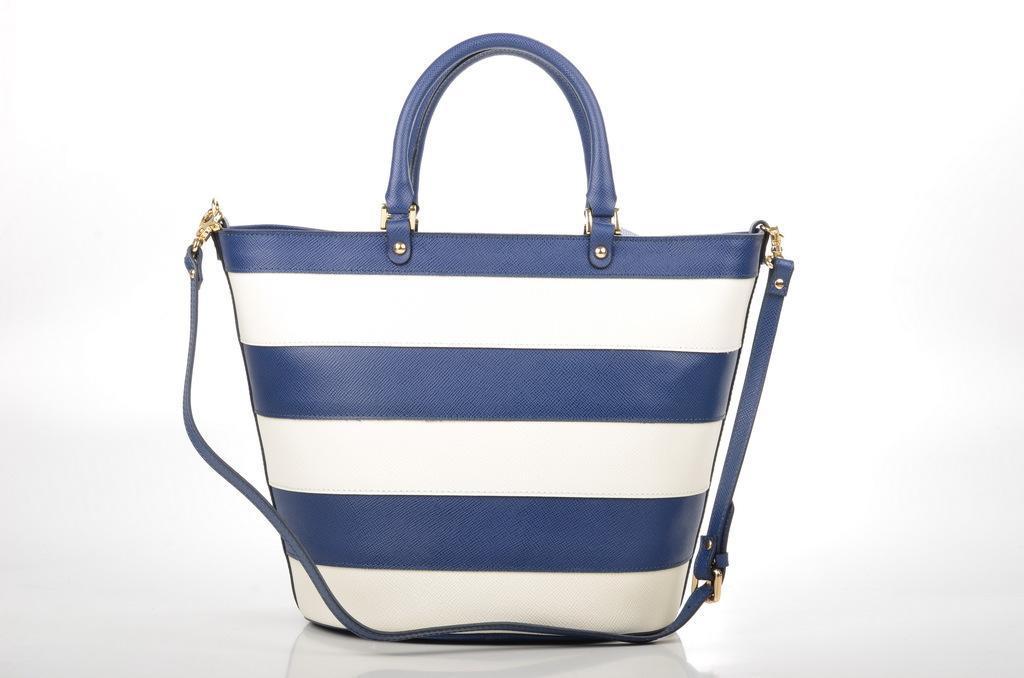Describe this image in one or two sentences. In the center we can see handbag which is in white and blue color. 